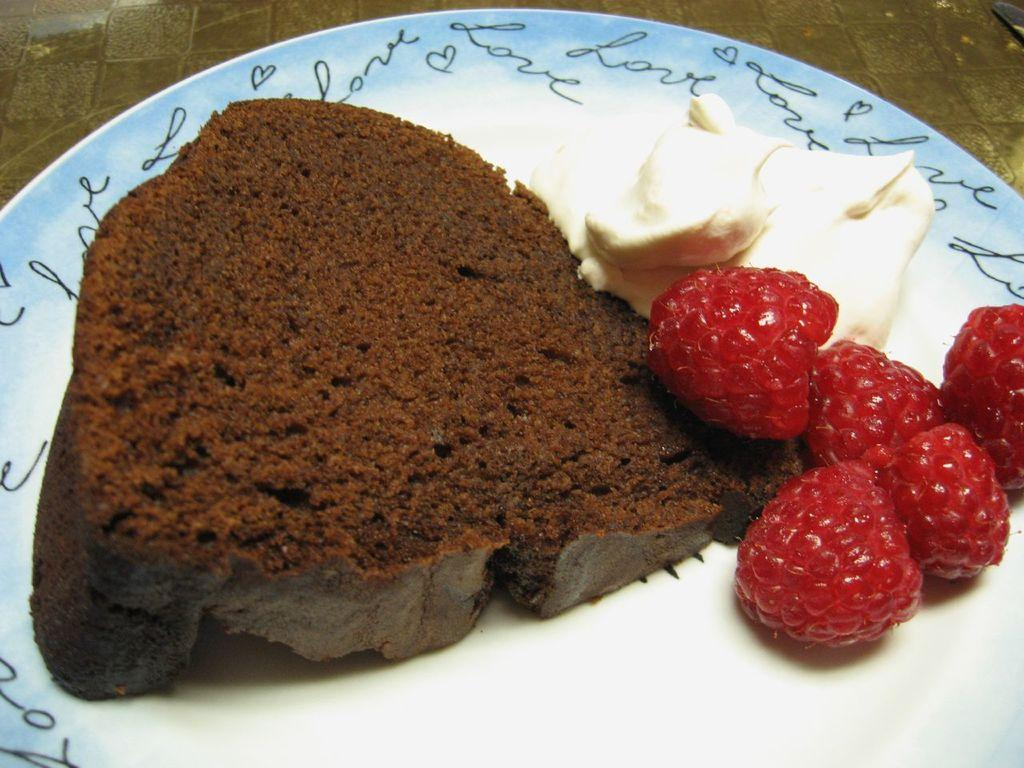What type of dessert is visible in the image? There is a slice of cake in the image. What is the cream used for in the image? The cream is used as a topping for the cake in the image. What type of fruit is present on the plate in the image? There are raspberries on the plate in the image. What page of the book is the man reading in the image? There is no man or book present in the image; it only features a slice of cake, cream, and raspberries. 